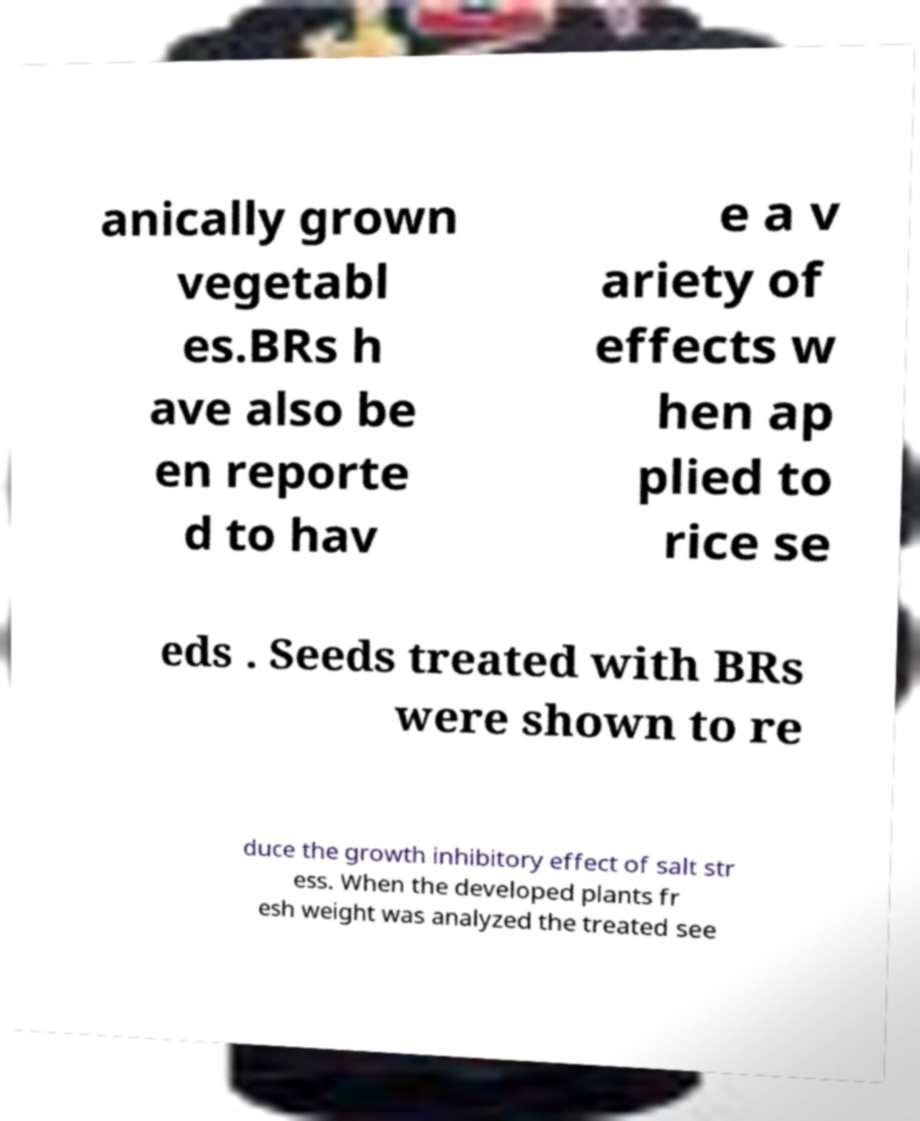I need the written content from this picture converted into text. Can you do that? anically grown vegetabl es.BRs h ave also be en reporte d to hav e a v ariety of effects w hen ap plied to rice se eds . Seeds treated with BRs were shown to re duce the growth inhibitory effect of salt str ess. When the developed plants fr esh weight was analyzed the treated see 